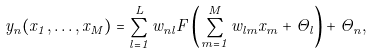<formula> <loc_0><loc_0><loc_500><loc_500>y _ { n } ( x _ { 1 } , \dots , x _ { M } ) = \sum _ { l = 1 } ^ { L } \widehat { w } _ { n l } F \left ( \sum _ { m = 1 } ^ { M } w _ { l m } x _ { m } + \Theta _ { l } \right ) + \widehat { \Theta } _ { n } ,</formula> 